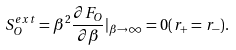Convert formula to latex. <formula><loc_0><loc_0><loc_500><loc_500>S ^ { e x t } _ { O } = \beta ^ { 2 } \frac { \partial F _ { O } } { \partial \beta } | _ { \beta \rightarrow \infty } = 0 ( r _ { + } = r _ { - } ) .</formula> 